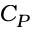<formula> <loc_0><loc_0><loc_500><loc_500>C _ { P }</formula> 